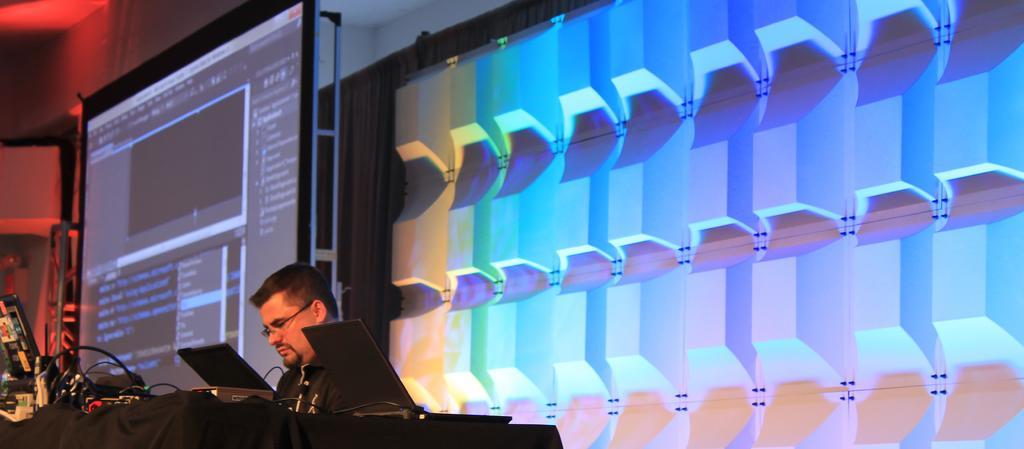Please provide a concise description of this image. In this picture there is a person wearing black dress is sitting and there is a table in front of him which has few laptops and some other objects on it and there are few lightnings behind him and there is a projected image in the left corner. 